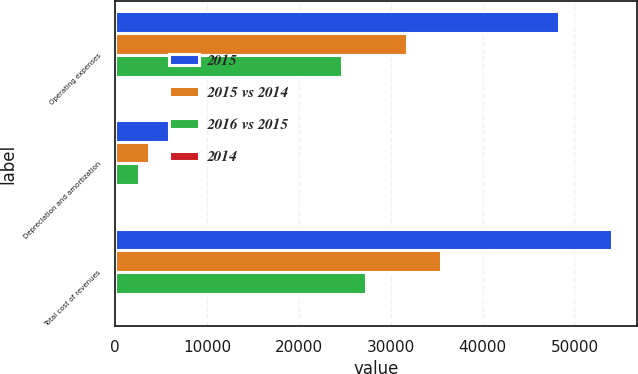Convert chart. <chart><loc_0><loc_0><loc_500><loc_500><stacked_bar_chart><ecel><fcel>Operating expenses<fcel>Depreciation and amortization<fcel>Total cost of revenues<nl><fcel>2015<fcel>48268<fcel>5798<fcel>54066<nl><fcel>2015 vs 2014<fcel>31790<fcel>3683<fcel>35473<nl><fcel>2016 vs 2015<fcel>24694<fcel>2624<fcel>27318<nl><fcel>2014<fcel>52<fcel>57<fcel>52<nl></chart> 